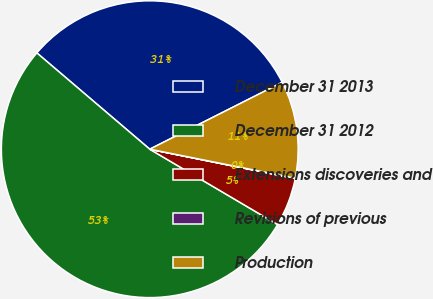Convert chart to OTSL. <chart><loc_0><loc_0><loc_500><loc_500><pie_chart><fcel>December 31 2013<fcel>December 31 2012<fcel>Extensions discoveries and<fcel>Revisions of previous<fcel>Production<nl><fcel>31.32%<fcel>52.76%<fcel>5.31%<fcel>0.03%<fcel>10.58%<nl></chart> 